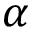Convert formula to latex. <formula><loc_0><loc_0><loc_500><loc_500>\alpha</formula> 